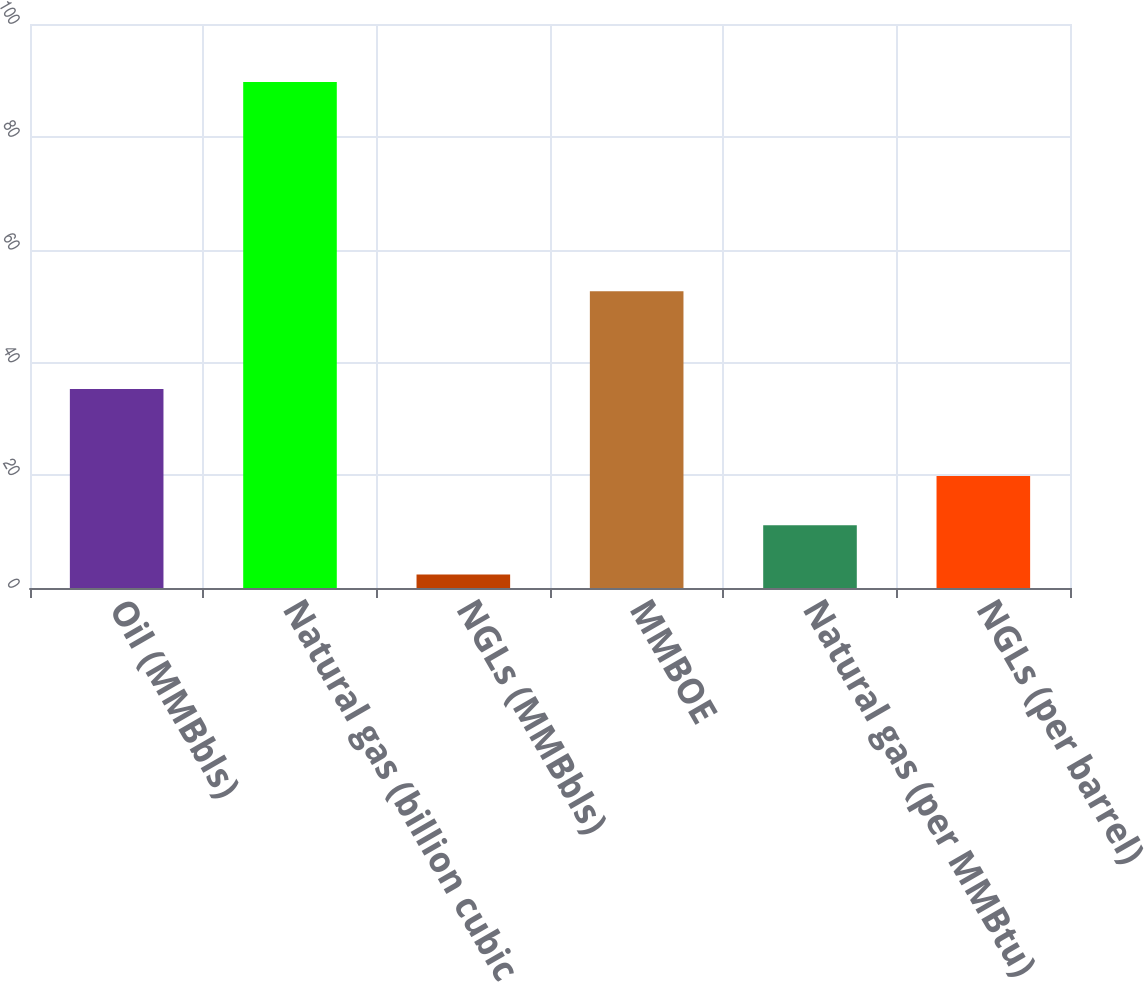<chart> <loc_0><loc_0><loc_500><loc_500><bar_chart><fcel>Oil (MMBbls)<fcel>Natural gas (billion cubic<fcel>NGLs (MMBbls)<fcel>MMBOE<fcel>Natural gas (per MMBtu)<fcel>NGLs (per barrel)<nl><fcel>35.3<fcel>89.7<fcel>2.4<fcel>52.6<fcel>11.13<fcel>19.86<nl></chart> 